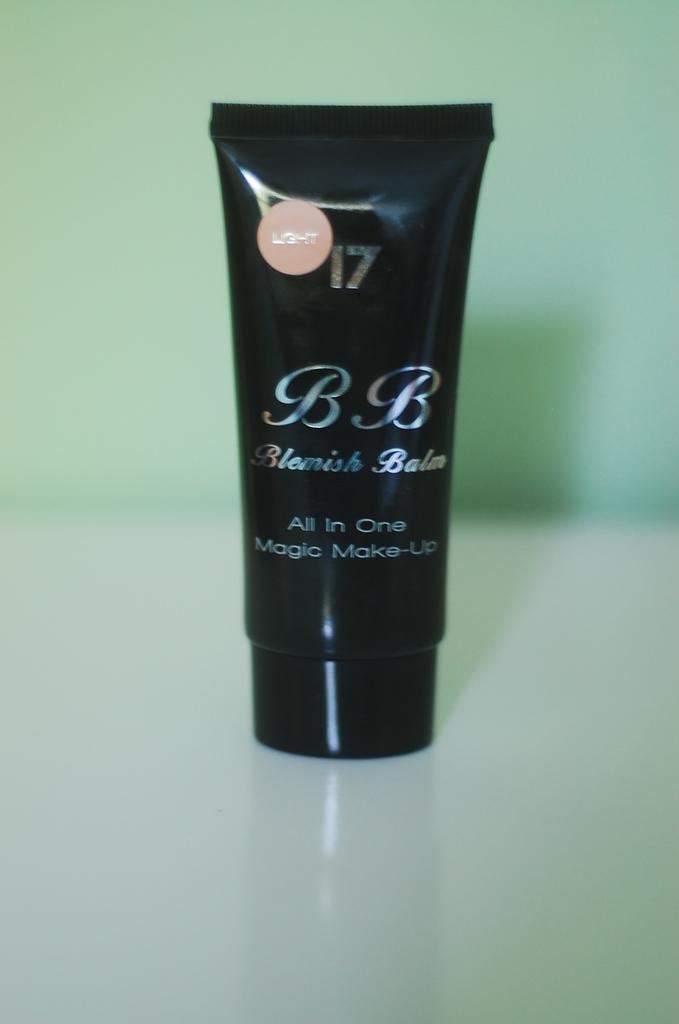<image>
Write a terse but informative summary of the picture. A black tube of Blemish Balm all in one magic make-up. 